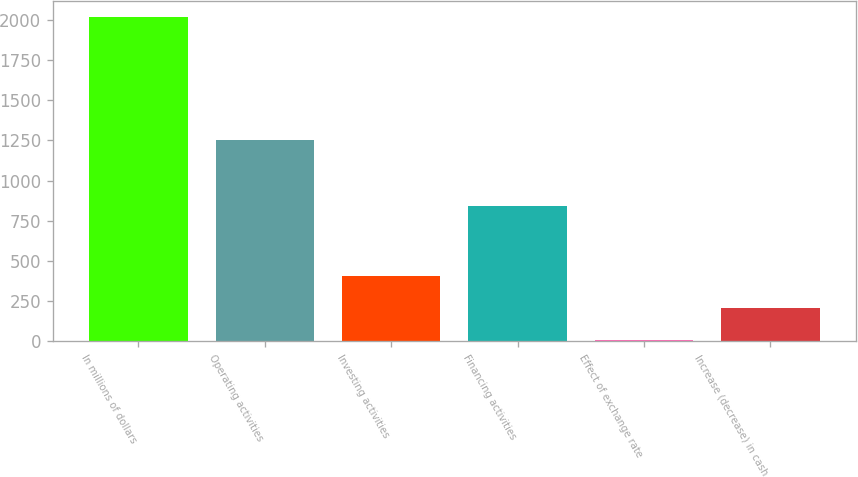<chart> <loc_0><loc_0><loc_500><loc_500><bar_chart><fcel>In millions of dollars<fcel>Operating activities<fcel>Investing activities<fcel>Financing activities<fcel>Effect of exchange rate<fcel>Increase (decrease) in cash<nl><fcel>2017<fcel>1249.5<fcel>408.28<fcel>843.8<fcel>6.1<fcel>207.19<nl></chart> 